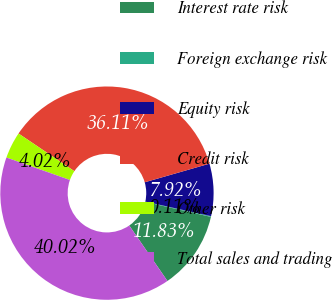Convert chart to OTSL. <chart><loc_0><loc_0><loc_500><loc_500><pie_chart><fcel>Interest rate risk<fcel>Foreign exchange risk<fcel>Equity risk<fcel>Credit risk<fcel>Other risk<fcel>Total sales and trading<nl><fcel>11.83%<fcel>0.11%<fcel>7.92%<fcel>36.11%<fcel>4.02%<fcel>40.02%<nl></chart> 